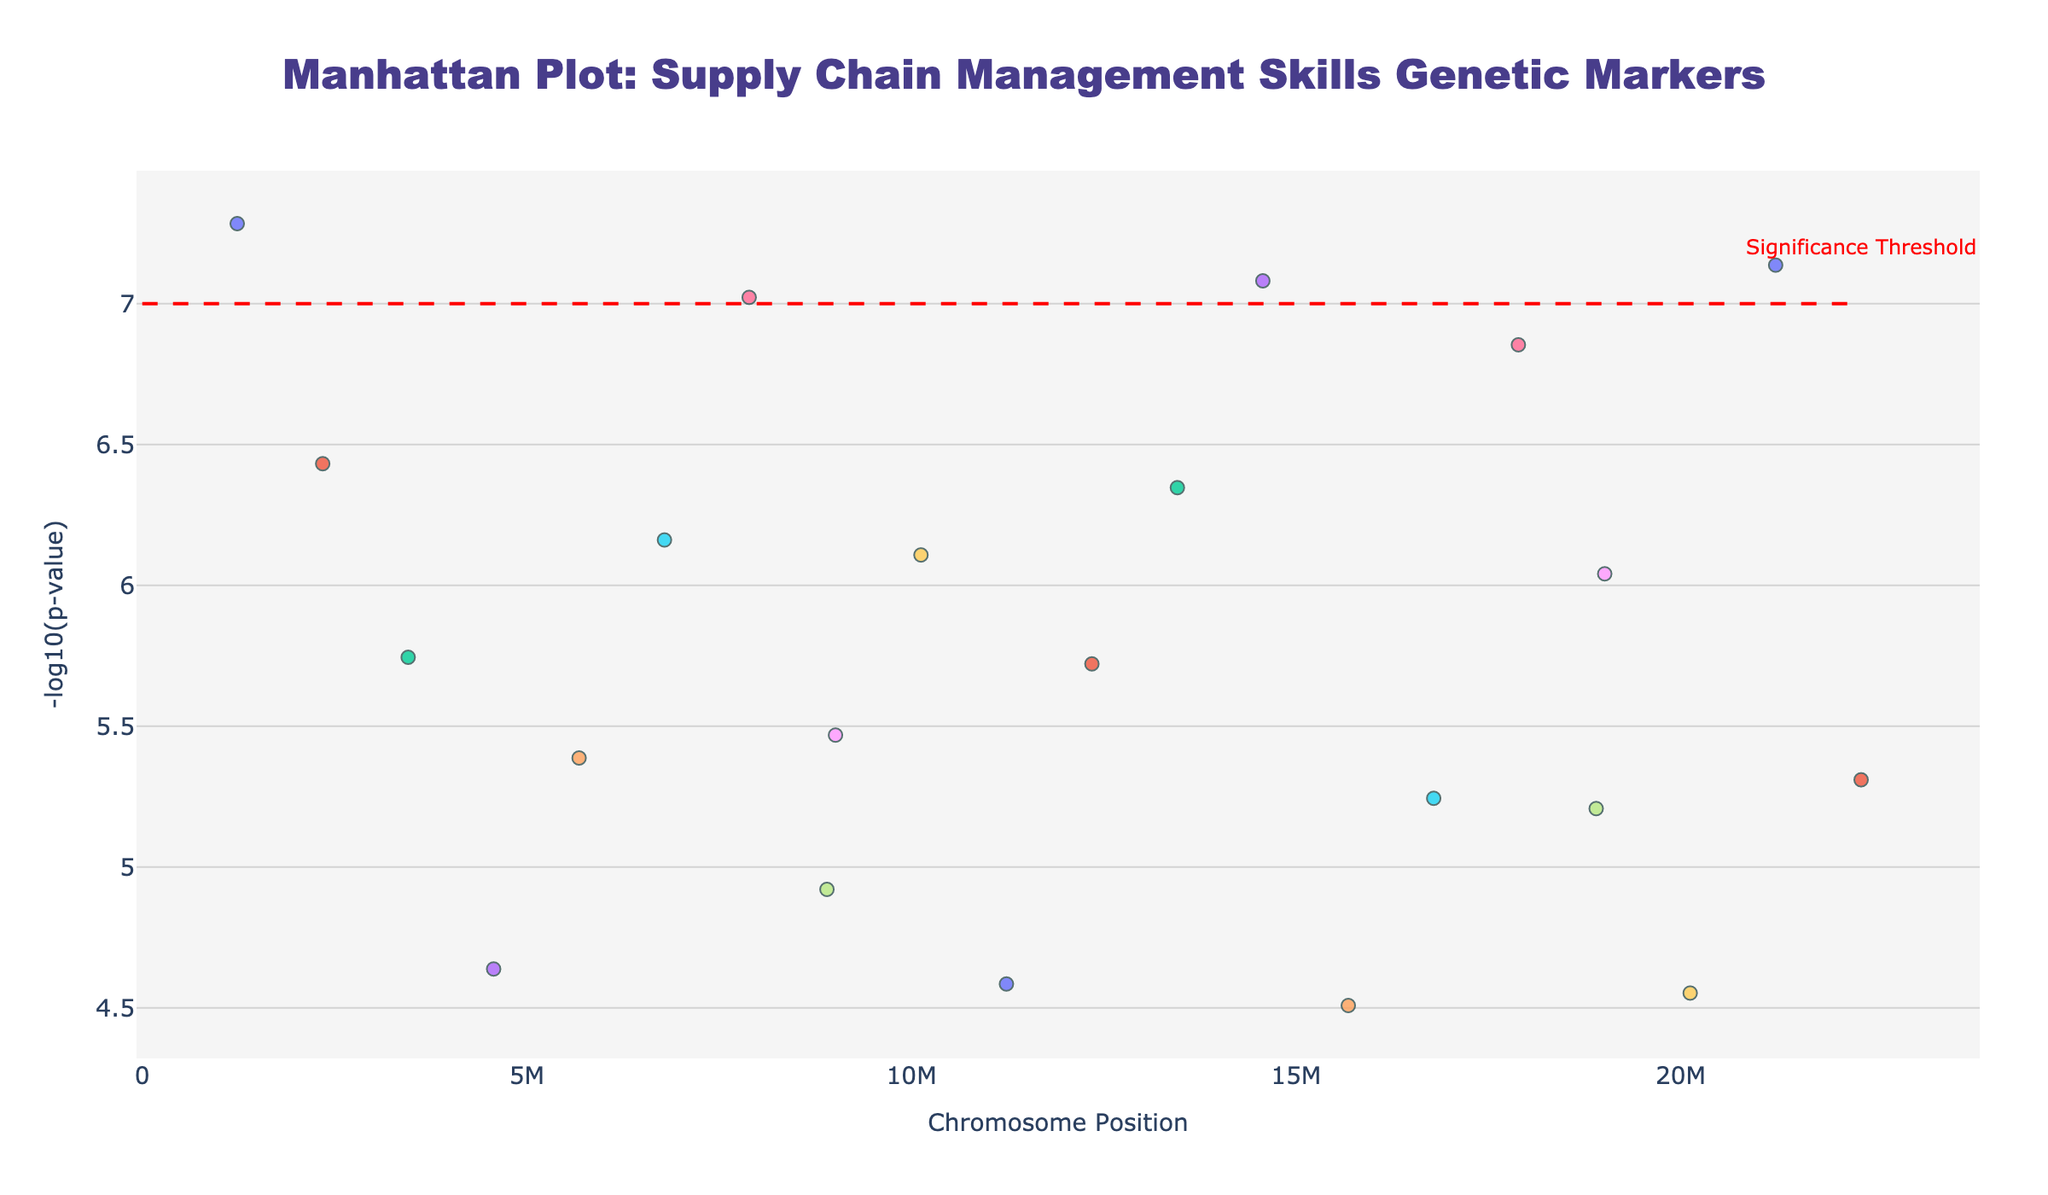What is the title of the figure? The title is found at the top of the plot in large, bold text. It helps to quickly understand the subject of the plot.
Answer: Manhattan Plot: Supply Chain Management Skills Genetic Markers What does the y-axis represent? The y-axis label indicates the variable being plotted along the vertical axis. In this plot, it is located on the left side.
Answer: -log10(p-value) How many chromosomes are represented in the plot? Each chromosome has a distinct set of data points, and this can be counted by looking at the number of unique 'Chromosome' labels used in the legend or by color coding in the plot.
Answer: 22 Which SNP has the lowest p-value? The lowest p-value corresponds to the highest -log10(p-value) on the y-axis. Finding the highest point on the plot will identify the SNP.
Answer: rs123456 How many data points lie above the significance threshold line? The significance threshold line is marked at y=7 on the plot. Counting the data points above this line will give the answer.
Answer: 3 Which chromosome has the SNP with the highest -log10(p-value)? The chromosome can be identified by looking at the x-axis position of the highest -log10(p-value) point and referencing the hover text or the color coding.
Answer: Chromosome 1 How does the significance threshold appear on the plot? The significance threshold is visually marked for easy identification. Describing its appearance provides insight into how thresholds are represented.
Answer: As a horizontal dashed red line at y=7 Compare the -log10(p-value) of SNPs on chromosome 7 and chromosome 14. Which one is higher? By locating the SNPs on chromosome 7 and 14 and comparing their -log10(p-value) values on the y-axis, we can identify which is higher.
Answer: Chromosome 14 What SNP is located at roughly the same chromosomal position on chromosome 10 and has significant results? By looking at the x-axis positions on chromosome 10 where the data points have high -log10(p-value), the specific SNP can be identified from the hover text.
Answer: rs012345 Which gene marker has the smallest visual representation on the y-axis? The smallest representation on the y-axis corresponds to the data point with the smallest -log10(p-value). The gene of this point can be found in the hover text.
Answer: PRCUR11 